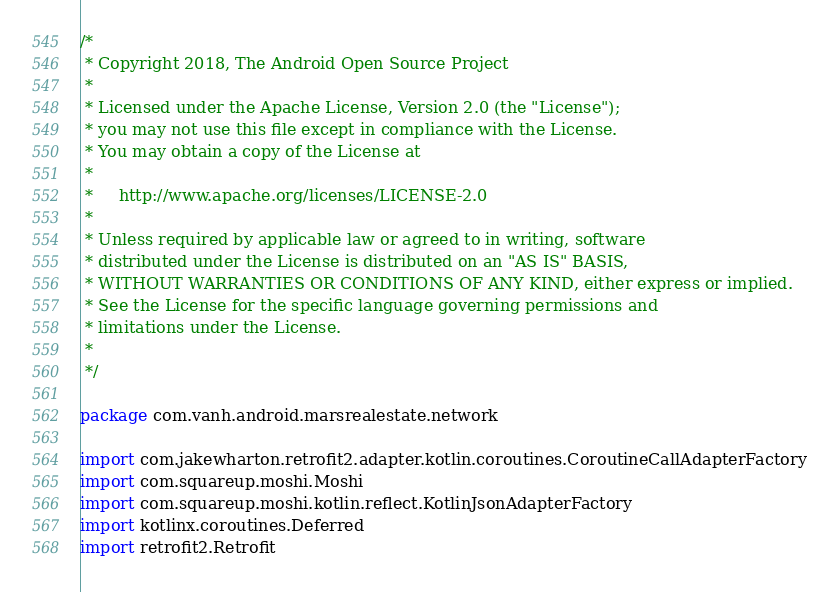<code> <loc_0><loc_0><loc_500><loc_500><_Kotlin_>/*
 * Copyright 2018, The Android Open Source Project
 *
 * Licensed under the Apache License, Version 2.0 (the "License");
 * you may not use this file except in compliance with the License.
 * You may obtain a copy of the License at
 *
 *     http://www.apache.org/licenses/LICENSE-2.0
 *
 * Unless required by applicable law or agreed to in writing, software
 * distributed under the License is distributed on an "AS IS" BASIS,
 * WITHOUT WARRANTIES OR CONDITIONS OF ANY KIND, either express or implied.
 * See the License for the specific language governing permissions and
 * limitations under the License.
 *
 */

package com.vanh.android.marsrealestate.network

import com.jakewharton.retrofit2.adapter.kotlin.coroutines.CoroutineCallAdapterFactory
import com.squareup.moshi.Moshi
import com.squareup.moshi.kotlin.reflect.KotlinJsonAdapterFactory
import kotlinx.coroutines.Deferred
import retrofit2.Retrofit</code> 